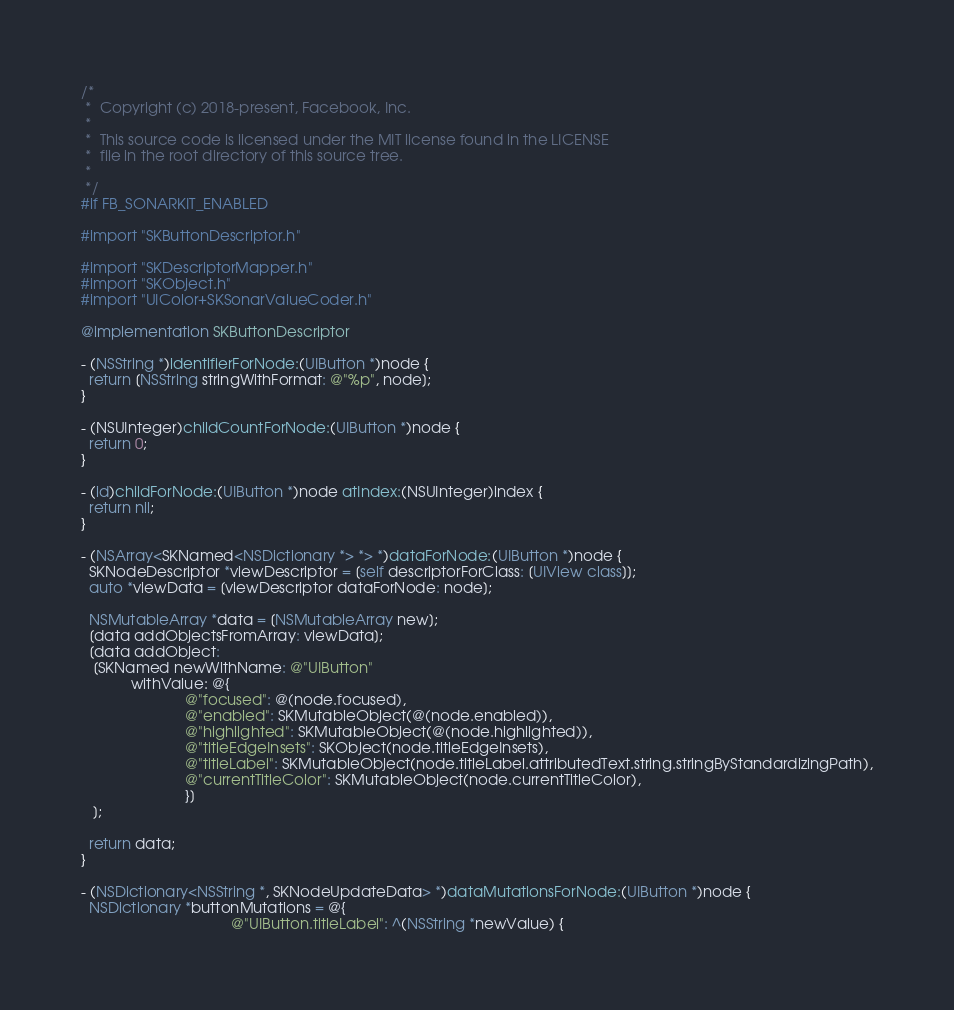Convert code to text. <code><loc_0><loc_0><loc_500><loc_500><_ObjectiveC_>/*
 *  Copyright (c) 2018-present, Facebook, Inc.
 *
 *  This source code is licensed under the MIT license found in the LICENSE
 *  file in the root directory of this source tree.
 *
 */
#if FB_SONARKIT_ENABLED

#import "SKButtonDescriptor.h"

#import "SKDescriptorMapper.h"
#import "SKObject.h"
#import "UIColor+SKSonarValueCoder.h"

@implementation SKButtonDescriptor

- (NSString *)identifierForNode:(UIButton *)node {
  return [NSString stringWithFormat: @"%p", node];
}

- (NSUInteger)childCountForNode:(UIButton *)node {
  return 0;
}

- (id)childForNode:(UIButton *)node atIndex:(NSUInteger)index {
  return nil;
}

- (NSArray<SKNamed<NSDictionary *> *> *)dataForNode:(UIButton *)node {
  SKNodeDescriptor *viewDescriptor = [self descriptorForClass: [UIView class]];
  auto *viewData = [viewDescriptor dataForNode: node];

  NSMutableArray *data = [NSMutableArray new];
  [data addObjectsFromArray: viewData];
  [data addObject:
   [SKNamed newWithName: @"UIButton"
            withValue: @{
                         @"focused": @(node.focused),
                         @"enabled": SKMutableObject(@(node.enabled)),
                         @"highlighted": SKMutableObject(@(node.highlighted)),
                         @"titleEdgeInsets": SKObject(node.titleEdgeInsets),
                         @"titleLabel": SKMutableObject(node.titleLabel.attributedText.string.stringByStandardizingPath),
                         @"currentTitleColor": SKMutableObject(node.currentTitleColor),
                         }]
   ];

  return data;
}

- (NSDictionary<NSString *, SKNodeUpdateData> *)dataMutationsForNode:(UIButton *)node {
  NSDictionary *buttonMutations = @{
                                    @"UIButton.titleLabel": ^(NSString *newValue) {</code> 